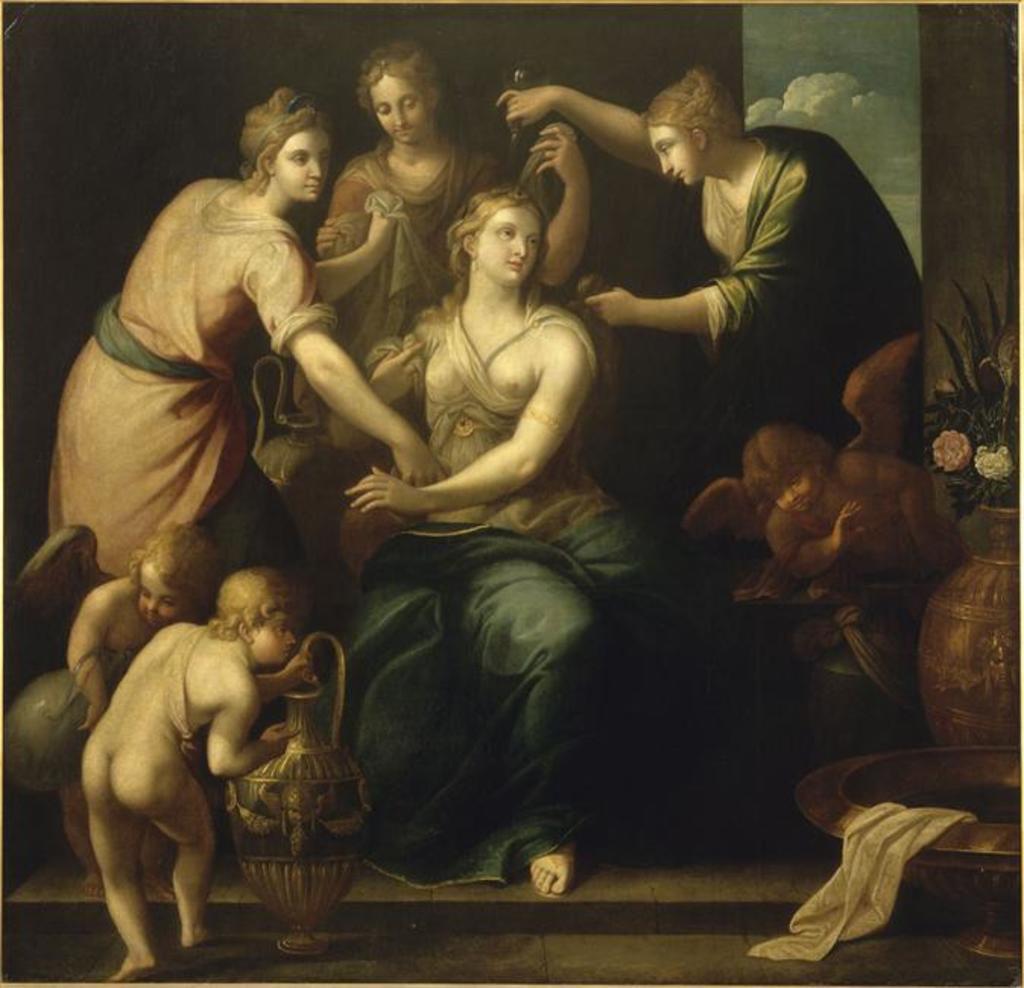Could you give a brief overview of what you see in this image? This image consists of a painting in which there are many persons. At the bottom, there are kids. And there four women in this image. On the right, we can see a flower vase. At the bottom, there is a floor. In the background, we can see the clouds in the sky. 